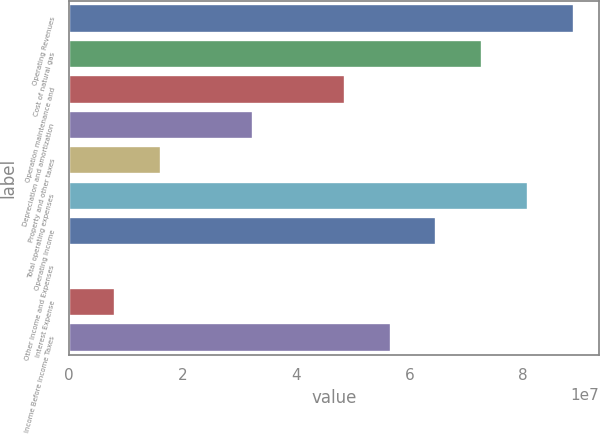<chart> <loc_0><loc_0><loc_500><loc_500><bar_chart><fcel>Operating Revenues<fcel>Cost of natural gas<fcel>Operation maintenance and<fcel>Depreciation and amortization<fcel>Property and other taxes<fcel>Total operating expenses<fcel>Operating Income<fcel>Other Income and Expenses<fcel>Interest Expense<fcel>Income Before Income Taxes<nl><fcel>8.90283e+07<fcel>7.28414e+07<fcel>4.85609e+07<fcel>3.2374e+07<fcel>1.6187e+07<fcel>8.09348e+07<fcel>6.47479e+07<fcel>66<fcel>8.09354e+06<fcel>5.66544e+07<nl></chart> 